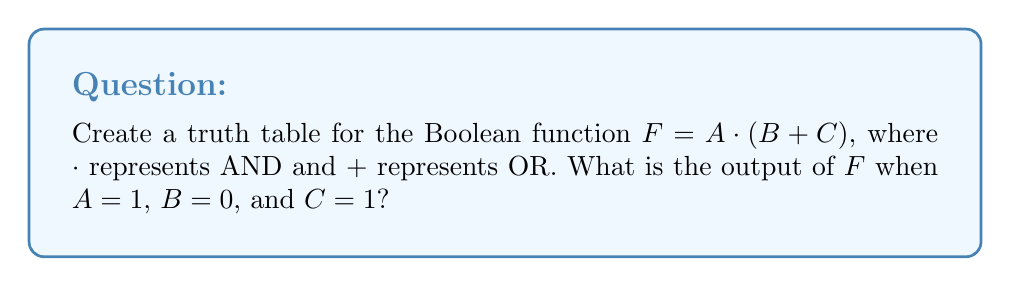Can you answer this question? Let's create the truth table step-by-step:

1. Identify the variables: $A$, $B$, and $C$

2. List all possible combinations of inputs:
   $$
   \begin{array}{|c|c|c|}
   \hline
   A & B & C \\
   \hline
   0 & 0 & 0 \\
   0 & 0 & 1 \\
   0 & 1 & 0 \\
   0 & 1 & 1 \\
   1 & 0 & 0 \\
   1 & 0 & 1 \\
   1 & 1 & 0 \\
   1 & 1 & 1 \\
   \hline
   \end{array}
   $$

3. Evaluate $B + C$:
   $$
   \begin{array}{|c|c|c|c|}
   \hline
   A & B & C & B+C \\
   \hline
   0 & 0 & 0 & 0 \\
   0 & 0 & 1 & 1 \\
   0 & 1 & 0 & 1 \\
   0 & 1 & 1 & 1 \\
   1 & 0 & 0 & 0 \\
   1 & 0 & 1 & 1 \\
   1 & 1 & 0 & 1 \\
   1 & 1 & 1 & 1 \\
   \hline
   \end{array}
   $$

4. Evaluate $F = A \cdot (B + C)$:
   $$
   \begin{array}{|c|c|c|c|c|}
   \hline
   A & B & C & B+C & F \\
   \hline
   0 & 0 & 0 & 0 & 0 \\
   0 & 0 & 1 & 1 & 0 \\
   0 & 1 & 0 & 1 & 0 \\
   0 & 1 & 1 & 1 & 0 \\
   1 & 0 & 0 & 0 & 0 \\
   1 & 0 & 1 & 1 & 1 \\
   1 & 1 & 0 & 1 & 1 \\
   1 & 1 & 1 & 1 & 1 \\
   \hline
   \end{array}
   $$

5. For $A=1$, $B=0$, and $C=1$:
   - Look at the 6th row of the truth table
   - $B + C = 1$
   - $F = A \cdot (B + C) = 1 \cdot 1 = 1$

Therefore, when $A=1$, $B=0$, and $C=1$, the output of $F$ is 1.
Answer: 1 